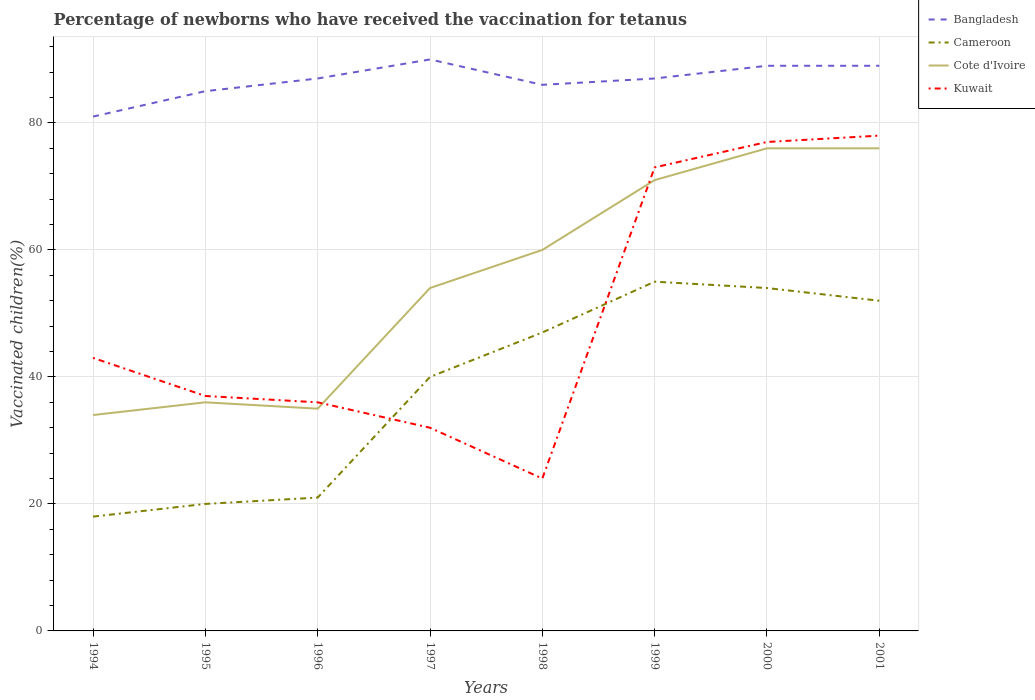How many different coloured lines are there?
Your answer should be compact. 4. Is the number of lines equal to the number of legend labels?
Give a very brief answer. Yes. Across all years, what is the maximum percentage of vaccinated children in Cameroon?
Offer a terse response. 18. In which year was the percentage of vaccinated children in Cote d'Ivoire maximum?
Make the answer very short. 1994. What is the difference between the highest and the second highest percentage of vaccinated children in Bangladesh?
Make the answer very short. 9. How many lines are there?
Make the answer very short. 4. What is the difference between two consecutive major ticks on the Y-axis?
Your answer should be compact. 20. Are the values on the major ticks of Y-axis written in scientific E-notation?
Ensure brevity in your answer.  No. Does the graph contain grids?
Offer a very short reply. Yes. How many legend labels are there?
Your response must be concise. 4. How are the legend labels stacked?
Your answer should be compact. Vertical. What is the title of the graph?
Your answer should be compact. Percentage of newborns who have received the vaccination for tetanus. What is the label or title of the X-axis?
Keep it short and to the point. Years. What is the label or title of the Y-axis?
Give a very brief answer. Vaccinated children(%). What is the Vaccinated children(%) of Cote d'Ivoire in 1994?
Provide a short and direct response. 34. What is the Vaccinated children(%) in Cameroon in 1995?
Give a very brief answer. 20. What is the Vaccinated children(%) in Cote d'Ivoire in 1995?
Keep it short and to the point. 36. What is the Vaccinated children(%) of Kuwait in 1995?
Your response must be concise. 37. What is the Vaccinated children(%) of Bangladesh in 1996?
Offer a terse response. 87. What is the Vaccinated children(%) of Kuwait in 1996?
Give a very brief answer. 36. What is the Vaccinated children(%) in Bangladesh in 1997?
Ensure brevity in your answer.  90. What is the Vaccinated children(%) of Cote d'Ivoire in 1997?
Your answer should be compact. 54. What is the Vaccinated children(%) in Kuwait in 1997?
Ensure brevity in your answer.  32. What is the Vaccinated children(%) of Cameroon in 1998?
Make the answer very short. 47. What is the Vaccinated children(%) in Cote d'Ivoire in 1998?
Your answer should be compact. 60. What is the Vaccinated children(%) of Kuwait in 1998?
Offer a very short reply. 24. What is the Vaccinated children(%) of Bangladesh in 1999?
Offer a very short reply. 87. What is the Vaccinated children(%) in Cameroon in 1999?
Provide a succinct answer. 55. What is the Vaccinated children(%) of Cote d'Ivoire in 1999?
Ensure brevity in your answer.  71. What is the Vaccinated children(%) in Bangladesh in 2000?
Provide a succinct answer. 89. What is the Vaccinated children(%) in Kuwait in 2000?
Keep it short and to the point. 77. What is the Vaccinated children(%) in Bangladesh in 2001?
Offer a terse response. 89. Across all years, what is the maximum Vaccinated children(%) in Bangladesh?
Your answer should be compact. 90. Across all years, what is the maximum Vaccinated children(%) of Cameroon?
Offer a terse response. 55. Across all years, what is the maximum Vaccinated children(%) in Cote d'Ivoire?
Your answer should be compact. 76. Across all years, what is the minimum Vaccinated children(%) in Bangladesh?
Your answer should be very brief. 81. Across all years, what is the minimum Vaccinated children(%) of Cameroon?
Keep it short and to the point. 18. Across all years, what is the minimum Vaccinated children(%) in Cote d'Ivoire?
Provide a succinct answer. 34. What is the total Vaccinated children(%) of Bangladesh in the graph?
Your response must be concise. 694. What is the total Vaccinated children(%) in Cameroon in the graph?
Keep it short and to the point. 307. What is the total Vaccinated children(%) in Cote d'Ivoire in the graph?
Provide a short and direct response. 442. What is the difference between the Vaccinated children(%) of Cote d'Ivoire in 1994 and that in 1995?
Your answer should be very brief. -2. What is the difference between the Vaccinated children(%) in Kuwait in 1994 and that in 1995?
Your response must be concise. 6. What is the difference between the Vaccinated children(%) in Cameroon in 1994 and that in 1996?
Keep it short and to the point. -3. What is the difference between the Vaccinated children(%) in Cameroon in 1994 and that in 1997?
Give a very brief answer. -22. What is the difference between the Vaccinated children(%) in Bangladesh in 1994 and that in 1998?
Offer a terse response. -5. What is the difference between the Vaccinated children(%) in Cameroon in 1994 and that in 1998?
Offer a very short reply. -29. What is the difference between the Vaccinated children(%) in Cote d'Ivoire in 1994 and that in 1998?
Your answer should be very brief. -26. What is the difference between the Vaccinated children(%) of Cameroon in 1994 and that in 1999?
Provide a succinct answer. -37. What is the difference between the Vaccinated children(%) in Cote d'Ivoire in 1994 and that in 1999?
Your answer should be compact. -37. What is the difference between the Vaccinated children(%) of Bangladesh in 1994 and that in 2000?
Keep it short and to the point. -8. What is the difference between the Vaccinated children(%) of Cameroon in 1994 and that in 2000?
Offer a very short reply. -36. What is the difference between the Vaccinated children(%) in Cote d'Ivoire in 1994 and that in 2000?
Your response must be concise. -42. What is the difference between the Vaccinated children(%) in Kuwait in 1994 and that in 2000?
Provide a succinct answer. -34. What is the difference between the Vaccinated children(%) in Bangladesh in 1994 and that in 2001?
Your answer should be compact. -8. What is the difference between the Vaccinated children(%) in Cameroon in 1994 and that in 2001?
Keep it short and to the point. -34. What is the difference between the Vaccinated children(%) of Cote d'Ivoire in 1994 and that in 2001?
Ensure brevity in your answer.  -42. What is the difference between the Vaccinated children(%) of Kuwait in 1994 and that in 2001?
Provide a succinct answer. -35. What is the difference between the Vaccinated children(%) of Kuwait in 1995 and that in 1997?
Your answer should be compact. 5. What is the difference between the Vaccinated children(%) of Cameroon in 1995 and that in 1998?
Offer a very short reply. -27. What is the difference between the Vaccinated children(%) in Cameroon in 1995 and that in 1999?
Give a very brief answer. -35. What is the difference between the Vaccinated children(%) of Cote d'Ivoire in 1995 and that in 1999?
Your response must be concise. -35. What is the difference between the Vaccinated children(%) in Kuwait in 1995 and that in 1999?
Give a very brief answer. -36. What is the difference between the Vaccinated children(%) in Cameroon in 1995 and that in 2000?
Keep it short and to the point. -34. What is the difference between the Vaccinated children(%) of Cote d'Ivoire in 1995 and that in 2000?
Ensure brevity in your answer.  -40. What is the difference between the Vaccinated children(%) of Kuwait in 1995 and that in 2000?
Provide a succinct answer. -40. What is the difference between the Vaccinated children(%) in Bangladesh in 1995 and that in 2001?
Your answer should be compact. -4. What is the difference between the Vaccinated children(%) of Cameroon in 1995 and that in 2001?
Provide a succinct answer. -32. What is the difference between the Vaccinated children(%) of Cote d'Ivoire in 1995 and that in 2001?
Your response must be concise. -40. What is the difference between the Vaccinated children(%) of Kuwait in 1995 and that in 2001?
Ensure brevity in your answer.  -41. What is the difference between the Vaccinated children(%) in Bangladesh in 1996 and that in 1997?
Your answer should be compact. -3. What is the difference between the Vaccinated children(%) of Cameroon in 1996 and that in 1997?
Ensure brevity in your answer.  -19. What is the difference between the Vaccinated children(%) in Kuwait in 1996 and that in 1997?
Provide a succinct answer. 4. What is the difference between the Vaccinated children(%) in Bangladesh in 1996 and that in 1998?
Offer a very short reply. 1. What is the difference between the Vaccinated children(%) of Cote d'Ivoire in 1996 and that in 1998?
Your response must be concise. -25. What is the difference between the Vaccinated children(%) of Bangladesh in 1996 and that in 1999?
Keep it short and to the point. 0. What is the difference between the Vaccinated children(%) of Cameroon in 1996 and that in 1999?
Make the answer very short. -34. What is the difference between the Vaccinated children(%) of Cote d'Ivoire in 1996 and that in 1999?
Make the answer very short. -36. What is the difference between the Vaccinated children(%) of Kuwait in 1996 and that in 1999?
Provide a succinct answer. -37. What is the difference between the Vaccinated children(%) in Bangladesh in 1996 and that in 2000?
Make the answer very short. -2. What is the difference between the Vaccinated children(%) of Cameroon in 1996 and that in 2000?
Offer a terse response. -33. What is the difference between the Vaccinated children(%) in Cote d'Ivoire in 1996 and that in 2000?
Provide a short and direct response. -41. What is the difference between the Vaccinated children(%) in Kuwait in 1996 and that in 2000?
Your response must be concise. -41. What is the difference between the Vaccinated children(%) of Cameroon in 1996 and that in 2001?
Ensure brevity in your answer.  -31. What is the difference between the Vaccinated children(%) in Cote d'Ivoire in 1996 and that in 2001?
Provide a short and direct response. -41. What is the difference between the Vaccinated children(%) of Kuwait in 1996 and that in 2001?
Your response must be concise. -42. What is the difference between the Vaccinated children(%) in Bangladesh in 1997 and that in 1998?
Provide a short and direct response. 4. What is the difference between the Vaccinated children(%) of Cote d'Ivoire in 1997 and that in 1998?
Give a very brief answer. -6. What is the difference between the Vaccinated children(%) of Kuwait in 1997 and that in 1998?
Give a very brief answer. 8. What is the difference between the Vaccinated children(%) in Bangladesh in 1997 and that in 1999?
Your answer should be very brief. 3. What is the difference between the Vaccinated children(%) in Cameroon in 1997 and that in 1999?
Ensure brevity in your answer.  -15. What is the difference between the Vaccinated children(%) of Kuwait in 1997 and that in 1999?
Your answer should be compact. -41. What is the difference between the Vaccinated children(%) of Kuwait in 1997 and that in 2000?
Make the answer very short. -45. What is the difference between the Vaccinated children(%) of Bangladesh in 1997 and that in 2001?
Ensure brevity in your answer.  1. What is the difference between the Vaccinated children(%) of Cameroon in 1997 and that in 2001?
Make the answer very short. -12. What is the difference between the Vaccinated children(%) in Kuwait in 1997 and that in 2001?
Your response must be concise. -46. What is the difference between the Vaccinated children(%) in Cameroon in 1998 and that in 1999?
Your response must be concise. -8. What is the difference between the Vaccinated children(%) in Cote d'Ivoire in 1998 and that in 1999?
Offer a very short reply. -11. What is the difference between the Vaccinated children(%) in Kuwait in 1998 and that in 1999?
Provide a succinct answer. -49. What is the difference between the Vaccinated children(%) of Bangladesh in 1998 and that in 2000?
Your answer should be compact. -3. What is the difference between the Vaccinated children(%) of Cameroon in 1998 and that in 2000?
Give a very brief answer. -7. What is the difference between the Vaccinated children(%) of Kuwait in 1998 and that in 2000?
Make the answer very short. -53. What is the difference between the Vaccinated children(%) in Bangladesh in 1998 and that in 2001?
Keep it short and to the point. -3. What is the difference between the Vaccinated children(%) in Cameroon in 1998 and that in 2001?
Provide a succinct answer. -5. What is the difference between the Vaccinated children(%) of Cote d'Ivoire in 1998 and that in 2001?
Provide a succinct answer. -16. What is the difference between the Vaccinated children(%) in Kuwait in 1998 and that in 2001?
Make the answer very short. -54. What is the difference between the Vaccinated children(%) of Cote d'Ivoire in 1999 and that in 2000?
Keep it short and to the point. -5. What is the difference between the Vaccinated children(%) of Kuwait in 1999 and that in 2000?
Your response must be concise. -4. What is the difference between the Vaccinated children(%) in Cameroon in 1999 and that in 2001?
Provide a succinct answer. 3. What is the difference between the Vaccinated children(%) of Cote d'Ivoire in 1999 and that in 2001?
Provide a succinct answer. -5. What is the difference between the Vaccinated children(%) in Kuwait in 1999 and that in 2001?
Offer a very short reply. -5. What is the difference between the Vaccinated children(%) of Cameroon in 2000 and that in 2001?
Offer a very short reply. 2. What is the difference between the Vaccinated children(%) in Kuwait in 2000 and that in 2001?
Provide a succinct answer. -1. What is the difference between the Vaccinated children(%) in Bangladesh in 1994 and the Vaccinated children(%) in Cameroon in 1995?
Provide a succinct answer. 61. What is the difference between the Vaccinated children(%) of Cote d'Ivoire in 1994 and the Vaccinated children(%) of Kuwait in 1995?
Your answer should be very brief. -3. What is the difference between the Vaccinated children(%) in Bangladesh in 1994 and the Vaccinated children(%) in Cote d'Ivoire in 1996?
Provide a short and direct response. 46. What is the difference between the Vaccinated children(%) of Bangladesh in 1994 and the Vaccinated children(%) of Kuwait in 1996?
Your response must be concise. 45. What is the difference between the Vaccinated children(%) of Cameroon in 1994 and the Vaccinated children(%) of Cote d'Ivoire in 1996?
Give a very brief answer. -17. What is the difference between the Vaccinated children(%) of Bangladesh in 1994 and the Vaccinated children(%) of Cameroon in 1997?
Give a very brief answer. 41. What is the difference between the Vaccinated children(%) in Bangladesh in 1994 and the Vaccinated children(%) in Cote d'Ivoire in 1997?
Offer a very short reply. 27. What is the difference between the Vaccinated children(%) of Cameroon in 1994 and the Vaccinated children(%) of Cote d'Ivoire in 1997?
Give a very brief answer. -36. What is the difference between the Vaccinated children(%) in Cameroon in 1994 and the Vaccinated children(%) in Kuwait in 1997?
Your response must be concise. -14. What is the difference between the Vaccinated children(%) of Cote d'Ivoire in 1994 and the Vaccinated children(%) of Kuwait in 1997?
Ensure brevity in your answer.  2. What is the difference between the Vaccinated children(%) of Bangladesh in 1994 and the Vaccinated children(%) of Kuwait in 1998?
Provide a short and direct response. 57. What is the difference between the Vaccinated children(%) of Cameroon in 1994 and the Vaccinated children(%) of Cote d'Ivoire in 1998?
Ensure brevity in your answer.  -42. What is the difference between the Vaccinated children(%) in Cameroon in 1994 and the Vaccinated children(%) in Kuwait in 1998?
Ensure brevity in your answer.  -6. What is the difference between the Vaccinated children(%) of Bangladesh in 1994 and the Vaccinated children(%) of Cameroon in 1999?
Offer a very short reply. 26. What is the difference between the Vaccinated children(%) of Bangladesh in 1994 and the Vaccinated children(%) of Cote d'Ivoire in 1999?
Provide a short and direct response. 10. What is the difference between the Vaccinated children(%) of Cameroon in 1994 and the Vaccinated children(%) of Cote d'Ivoire in 1999?
Your answer should be very brief. -53. What is the difference between the Vaccinated children(%) in Cameroon in 1994 and the Vaccinated children(%) in Kuwait in 1999?
Your answer should be very brief. -55. What is the difference between the Vaccinated children(%) in Cote d'Ivoire in 1994 and the Vaccinated children(%) in Kuwait in 1999?
Make the answer very short. -39. What is the difference between the Vaccinated children(%) of Bangladesh in 1994 and the Vaccinated children(%) of Cameroon in 2000?
Your answer should be compact. 27. What is the difference between the Vaccinated children(%) in Bangladesh in 1994 and the Vaccinated children(%) in Cote d'Ivoire in 2000?
Provide a succinct answer. 5. What is the difference between the Vaccinated children(%) of Bangladesh in 1994 and the Vaccinated children(%) of Kuwait in 2000?
Your answer should be very brief. 4. What is the difference between the Vaccinated children(%) of Cameroon in 1994 and the Vaccinated children(%) of Cote d'Ivoire in 2000?
Keep it short and to the point. -58. What is the difference between the Vaccinated children(%) of Cameroon in 1994 and the Vaccinated children(%) of Kuwait in 2000?
Your answer should be compact. -59. What is the difference between the Vaccinated children(%) in Cote d'Ivoire in 1994 and the Vaccinated children(%) in Kuwait in 2000?
Your answer should be compact. -43. What is the difference between the Vaccinated children(%) of Cameroon in 1994 and the Vaccinated children(%) of Cote d'Ivoire in 2001?
Ensure brevity in your answer.  -58. What is the difference between the Vaccinated children(%) of Cameroon in 1994 and the Vaccinated children(%) of Kuwait in 2001?
Your answer should be compact. -60. What is the difference between the Vaccinated children(%) in Cote d'Ivoire in 1994 and the Vaccinated children(%) in Kuwait in 2001?
Your response must be concise. -44. What is the difference between the Vaccinated children(%) of Bangladesh in 1995 and the Vaccinated children(%) of Cote d'Ivoire in 1996?
Your answer should be very brief. 50. What is the difference between the Vaccinated children(%) in Cameroon in 1995 and the Vaccinated children(%) in Cote d'Ivoire in 1996?
Give a very brief answer. -15. What is the difference between the Vaccinated children(%) in Bangladesh in 1995 and the Vaccinated children(%) in Cote d'Ivoire in 1997?
Provide a succinct answer. 31. What is the difference between the Vaccinated children(%) of Cameroon in 1995 and the Vaccinated children(%) of Cote d'Ivoire in 1997?
Your answer should be compact. -34. What is the difference between the Vaccinated children(%) in Cote d'Ivoire in 1995 and the Vaccinated children(%) in Kuwait in 1997?
Offer a terse response. 4. What is the difference between the Vaccinated children(%) in Cameroon in 1995 and the Vaccinated children(%) in Cote d'Ivoire in 1998?
Ensure brevity in your answer.  -40. What is the difference between the Vaccinated children(%) of Bangladesh in 1995 and the Vaccinated children(%) of Cote d'Ivoire in 1999?
Your answer should be very brief. 14. What is the difference between the Vaccinated children(%) in Bangladesh in 1995 and the Vaccinated children(%) in Kuwait in 1999?
Your answer should be very brief. 12. What is the difference between the Vaccinated children(%) in Cameroon in 1995 and the Vaccinated children(%) in Cote d'Ivoire in 1999?
Your response must be concise. -51. What is the difference between the Vaccinated children(%) in Cameroon in 1995 and the Vaccinated children(%) in Kuwait in 1999?
Offer a terse response. -53. What is the difference between the Vaccinated children(%) in Cote d'Ivoire in 1995 and the Vaccinated children(%) in Kuwait in 1999?
Keep it short and to the point. -37. What is the difference between the Vaccinated children(%) of Bangladesh in 1995 and the Vaccinated children(%) of Kuwait in 2000?
Provide a short and direct response. 8. What is the difference between the Vaccinated children(%) in Cameroon in 1995 and the Vaccinated children(%) in Cote d'Ivoire in 2000?
Offer a very short reply. -56. What is the difference between the Vaccinated children(%) in Cameroon in 1995 and the Vaccinated children(%) in Kuwait in 2000?
Provide a succinct answer. -57. What is the difference between the Vaccinated children(%) in Cote d'Ivoire in 1995 and the Vaccinated children(%) in Kuwait in 2000?
Offer a very short reply. -41. What is the difference between the Vaccinated children(%) in Bangladesh in 1995 and the Vaccinated children(%) in Cote d'Ivoire in 2001?
Offer a very short reply. 9. What is the difference between the Vaccinated children(%) of Bangladesh in 1995 and the Vaccinated children(%) of Kuwait in 2001?
Your answer should be compact. 7. What is the difference between the Vaccinated children(%) in Cameroon in 1995 and the Vaccinated children(%) in Cote d'Ivoire in 2001?
Provide a short and direct response. -56. What is the difference between the Vaccinated children(%) in Cameroon in 1995 and the Vaccinated children(%) in Kuwait in 2001?
Give a very brief answer. -58. What is the difference between the Vaccinated children(%) of Cote d'Ivoire in 1995 and the Vaccinated children(%) of Kuwait in 2001?
Ensure brevity in your answer.  -42. What is the difference between the Vaccinated children(%) in Bangladesh in 1996 and the Vaccinated children(%) in Cote d'Ivoire in 1997?
Ensure brevity in your answer.  33. What is the difference between the Vaccinated children(%) of Cameroon in 1996 and the Vaccinated children(%) of Cote d'Ivoire in 1997?
Your answer should be very brief. -33. What is the difference between the Vaccinated children(%) of Cameroon in 1996 and the Vaccinated children(%) of Kuwait in 1997?
Your response must be concise. -11. What is the difference between the Vaccinated children(%) of Bangladesh in 1996 and the Vaccinated children(%) of Cameroon in 1998?
Your answer should be very brief. 40. What is the difference between the Vaccinated children(%) in Bangladesh in 1996 and the Vaccinated children(%) in Cote d'Ivoire in 1998?
Keep it short and to the point. 27. What is the difference between the Vaccinated children(%) in Cameroon in 1996 and the Vaccinated children(%) in Cote d'Ivoire in 1998?
Give a very brief answer. -39. What is the difference between the Vaccinated children(%) in Cameroon in 1996 and the Vaccinated children(%) in Kuwait in 1998?
Your response must be concise. -3. What is the difference between the Vaccinated children(%) of Cote d'Ivoire in 1996 and the Vaccinated children(%) of Kuwait in 1998?
Offer a very short reply. 11. What is the difference between the Vaccinated children(%) of Bangladesh in 1996 and the Vaccinated children(%) of Cameroon in 1999?
Provide a succinct answer. 32. What is the difference between the Vaccinated children(%) in Bangladesh in 1996 and the Vaccinated children(%) in Kuwait in 1999?
Your response must be concise. 14. What is the difference between the Vaccinated children(%) in Cameroon in 1996 and the Vaccinated children(%) in Kuwait in 1999?
Offer a very short reply. -52. What is the difference between the Vaccinated children(%) in Cote d'Ivoire in 1996 and the Vaccinated children(%) in Kuwait in 1999?
Offer a terse response. -38. What is the difference between the Vaccinated children(%) of Bangladesh in 1996 and the Vaccinated children(%) of Cote d'Ivoire in 2000?
Provide a succinct answer. 11. What is the difference between the Vaccinated children(%) in Bangladesh in 1996 and the Vaccinated children(%) in Kuwait in 2000?
Your answer should be compact. 10. What is the difference between the Vaccinated children(%) of Cameroon in 1996 and the Vaccinated children(%) of Cote d'Ivoire in 2000?
Keep it short and to the point. -55. What is the difference between the Vaccinated children(%) in Cameroon in 1996 and the Vaccinated children(%) in Kuwait in 2000?
Keep it short and to the point. -56. What is the difference between the Vaccinated children(%) in Cote d'Ivoire in 1996 and the Vaccinated children(%) in Kuwait in 2000?
Offer a terse response. -42. What is the difference between the Vaccinated children(%) in Bangladesh in 1996 and the Vaccinated children(%) in Cameroon in 2001?
Give a very brief answer. 35. What is the difference between the Vaccinated children(%) in Bangladesh in 1996 and the Vaccinated children(%) in Kuwait in 2001?
Offer a very short reply. 9. What is the difference between the Vaccinated children(%) of Cameroon in 1996 and the Vaccinated children(%) of Cote d'Ivoire in 2001?
Ensure brevity in your answer.  -55. What is the difference between the Vaccinated children(%) in Cameroon in 1996 and the Vaccinated children(%) in Kuwait in 2001?
Provide a short and direct response. -57. What is the difference between the Vaccinated children(%) of Cote d'Ivoire in 1996 and the Vaccinated children(%) of Kuwait in 2001?
Provide a short and direct response. -43. What is the difference between the Vaccinated children(%) of Bangladesh in 1997 and the Vaccinated children(%) of Kuwait in 1998?
Give a very brief answer. 66. What is the difference between the Vaccinated children(%) of Cameroon in 1997 and the Vaccinated children(%) of Cote d'Ivoire in 1998?
Keep it short and to the point. -20. What is the difference between the Vaccinated children(%) in Cameroon in 1997 and the Vaccinated children(%) in Kuwait in 1998?
Provide a short and direct response. 16. What is the difference between the Vaccinated children(%) of Cote d'Ivoire in 1997 and the Vaccinated children(%) of Kuwait in 1998?
Offer a very short reply. 30. What is the difference between the Vaccinated children(%) in Bangladesh in 1997 and the Vaccinated children(%) in Cote d'Ivoire in 1999?
Your response must be concise. 19. What is the difference between the Vaccinated children(%) in Cameroon in 1997 and the Vaccinated children(%) in Cote d'Ivoire in 1999?
Your response must be concise. -31. What is the difference between the Vaccinated children(%) in Cameroon in 1997 and the Vaccinated children(%) in Kuwait in 1999?
Make the answer very short. -33. What is the difference between the Vaccinated children(%) of Cote d'Ivoire in 1997 and the Vaccinated children(%) of Kuwait in 1999?
Make the answer very short. -19. What is the difference between the Vaccinated children(%) of Cameroon in 1997 and the Vaccinated children(%) of Cote d'Ivoire in 2000?
Provide a short and direct response. -36. What is the difference between the Vaccinated children(%) of Cameroon in 1997 and the Vaccinated children(%) of Kuwait in 2000?
Your response must be concise. -37. What is the difference between the Vaccinated children(%) in Bangladesh in 1997 and the Vaccinated children(%) in Cote d'Ivoire in 2001?
Provide a short and direct response. 14. What is the difference between the Vaccinated children(%) of Cameroon in 1997 and the Vaccinated children(%) of Cote d'Ivoire in 2001?
Make the answer very short. -36. What is the difference between the Vaccinated children(%) in Cameroon in 1997 and the Vaccinated children(%) in Kuwait in 2001?
Offer a very short reply. -38. What is the difference between the Vaccinated children(%) of Bangladesh in 1998 and the Vaccinated children(%) of Kuwait in 1999?
Ensure brevity in your answer.  13. What is the difference between the Vaccinated children(%) in Cameroon in 1998 and the Vaccinated children(%) in Cote d'Ivoire in 1999?
Ensure brevity in your answer.  -24. What is the difference between the Vaccinated children(%) of Cameroon in 1998 and the Vaccinated children(%) of Kuwait in 1999?
Provide a short and direct response. -26. What is the difference between the Vaccinated children(%) of Cote d'Ivoire in 1998 and the Vaccinated children(%) of Kuwait in 1999?
Provide a short and direct response. -13. What is the difference between the Vaccinated children(%) of Bangladesh in 1998 and the Vaccinated children(%) of Cameroon in 2000?
Your answer should be very brief. 32. What is the difference between the Vaccinated children(%) in Bangladesh in 1998 and the Vaccinated children(%) in Cote d'Ivoire in 2000?
Provide a short and direct response. 10. What is the difference between the Vaccinated children(%) in Cameroon in 1998 and the Vaccinated children(%) in Cote d'Ivoire in 2000?
Your response must be concise. -29. What is the difference between the Vaccinated children(%) in Cote d'Ivoire in 1998 and the Vaccinated children(%) in Kuwait in 2000?
Ensure brevity in your answer.  -17. What is the difference between the Vaccinated children(%) of Bangladesh in 1998 and the Vaccinated children(%) of Cote d'Ivoire in 2001?
Your answer should be very brief. 10. What is the difference between the Vaccinated children(%) of Cameroon in 1998 and the Vaccinated children(%) of Kuwait in 2001?
Keep it short and to the point. -31. What is the difference between the Vaccinated children(%) of Bangladesh in 1999 and the Vaccinated children(%) of Cameroon in 2000?
Make the answer very short. 33. What is the difference between the Vaccinated children(%) in Bangladesh in 1999 and the Vaccinated children(%) in Cote d'Ivoire in 2000?
Ensure brevity in your answer.  11. What is the difference between the Vaccinated children(%) of Cameroon in 1999 and the Vaccinated children(%) of Cote d'Ivoire in 2000?
Your answer should be very brief. -21. What is the difference between the Vaccinated children(%) in Cameroon in 1999 and the Vaccinated children(%) in Kuwait in 2000?
Provide a short and direct response. -22. What is the difference between the Vaccinated children(%) of Bangladesh in 1999 and the Vaccinated children(%) of Cameroon in 2001?
Your answer should be very brief. 35. What is the difference between the Vaccinated children(%) in Bangladesh in 1999 and the Vaccinated children(%) in Cote d'Ivoire in 2001?
Your answer should be compact. 11. What is the difference between the Vaccinated children(%) of Cameroon in 1999 and the Vaccinated children(%) of Kuwait in 2001?
Give a very brief answer. -23. What is the difference between the Vaccinated children(%) in Cote d'Ivoire in 1999 and the Vaccinated children(%) in Kuwait in 2001?
Give a very brief answer. -7. What is the difference between the Vaccinated children(%) in Bangladesh in 2000 and the Vaccinated children(%) in Cameroon in 2001?
Ensure brevity in your answer.  37. What is the difference between the Vaccinated children(%) in Bangladesh in 2000 and the Vaccinated children(%) in Cote d'Ivoire in 2001?
Keep it short and to the point. 13. What is the difference between the Vaccinated children(%) in Bangladesh in 2000 and the Vaccinated children(%) in Kuwait in 2001?
Your answer should be compact. 11. What is the difference between the Vaccinated children(%) of Cameroon in 2000 and the Vaccinated children(%) of Kuwait in 2001?
Keep it short and to the point. -24. What is the average Vaccinated children(%) of Bangladesh per year?
Your response must be concise. 86.75. What is the average Vaccinated children(%) of Cameroon per year?
Offer a very short reply. 38.38. What is the average Vaccinated children(%) of Cote d'Ivoire per year?
Ensure brevity in your answer.  55.25. In the year 1994, what is the difference between the Vaccinated children(%) in Cameroon and Vaccinated children(%) in Kuwait?
Offer a terse response. -25. In the year 1995, what is the difference between the Vaccinated children(%) of Bangladesh and Vaccinated children(%) of Cameroon?
Your answer should be very brief. 65. In the year 1995, what is the difference between the Vaccinated children(%) of Cameroon and Vaccinated children(%) of Kuwait?
Make the answer very short. -17. In the year 1995, what is the difference between the Vaccinated children(%) of Cote d'Ivoire and Vaccinated children(%) of Kuwait?
Keep it short and to the point. -1. In the year 1996, what is the difference between the Vaccinated children(%) of Bangladesh and Vaccinated children(%) of Kuwait?
Make the answer very short. 51. In the year 1996, what is the difference between the Vaccinated children(%) in Cote d'Ivoire and Vaccinated children(%) in Kuwait?
Ensure brevity in your answer.  -1. In the year 1997, what is the difference between the Vaccinated children(%) in Bangladesh and Vaccinated children(%) in Cote d'Ivoire?
Offer a terse response. 36. In the year 1997, what is the difference between the Vaccinated children(%) of Cameroon and Vaccinated children(%) of Cote d'Ivoire?
Your answer should be compact. -14. In the year 1997, what is the difference between the Vaccinated children(%) of Cameroon and Vaccinated children(%) of Kuwait?
Keep it short and to the point. 8. In the year 1998, what is the difference between the Vaccinated children(%) of Cameroon and Vaccinated children(%) of Cote d'Ivoire?
Make the answer very short. -13. In the year 1999, what is the difference between the Vaccinated children(%) in Bangladesh and Vaccinated children(%) in Cote d'Ivoire?
Offer a terse response. 16. In the year 1999, what is the difference between the Vaccinated children(%) of Bangladesh and Vaccinated children(%) of Kuwait?
Make the answer very short. 14. In the year 2000, what is the difference between the Vaccinated children(%) of Bangladesh and Vaccinated children(%) of Cote d'Ivoire?
Ensure brevity in your answer.  13. In the year 2000, what is the difference between the Vaccinated children(%) in Cameroon and Vaccinated children(%) in Kuwait?
Keep it short and to the point. -23. In the year 2000, what is the difference between the Vaccinated children(%) in Cote d'Ivoire and Vaccinated children(%) in Kuwait?
Provide a short and direct response. -1. In the year 2001, what is the difference between the Vaccinated children(%) in Cameroon and Vaccinated children(%) in Kuwait?
Your response must be concise. -26. What is the ratio of the Vaccinated children(%) of Bangladesh in 1994 to that in 1995?
Provide a short and direct response. 0.95. What is the ratio of the Vaccinated children(%) of Kuwait in 1994 to that in 1995?
Provide a succinct answer. 1.16. What is the ratio of the Vaccinated children(%) in Bangladesh in 1994 to that in 1996?
Keep it short and to the point. 0.93. What is the ratio of the Vaccinated children(%) of Cameroon in 1994 to that in 1996?
Ensure brevity in your answer.  0.86. What is the ratio of the Vaccinated children(%) of Cote d'Ivoire in 1994 to that in 1996?
Provide a succinct answer. 0.97. What is the ratio of the Vaccinated children(%) in Kuwait in 1994 to that in 1996?
Provide a short and direct response. 1.19. What is the ratio of the Vaccinated children(%) of Cameroon in 1994 to that in 1997?
Your answer should be compact. 0.45. What is the ratio of the Vaccinated children(%) of Cote d'Ivoire in 1994 to that in 1997?
Your answer should be very brief. 0.63. What is the ratio of the Vaccinated children(%) of Kuwait in 1994 to that in 1997?
Ensure brevity in your answer.  1.34. What is the ratio of the Vaccinated children(%) in Bangladesh in 1994 to that in 1998?
Make the answer very short. 0.94. What is the ratio of the Vaccinated children(%) of Cameroon in 1994 to that in 1998?
Your answer should be compact. 0.38. What is the ratio of the Vaccinated children(%) of Cote d'Ivoire in 1994 to that in 1998?
Ensure brevity in your answer.  0.57. What is the ratio of the Vaccinated children(%) in Kuwait in 1994 to that in 1998?
Your answer should be very brief. 1.79. What is the ratio of the Vaccinated children(%) of Bangladesh in 1994 to that in 1999?
Give a very brief answer. 0.93. What is the ratio of the Vaccinated children(%) of Cameroon in 1994 to that in 1999?
Provide a short and direct response. 0.33. What is the ratio of the Vaccinated children(%) of Cote d'Ivoire in 1994 to that in 1999?
Your answer should be very brief. 0.48. What is the ratio of the Vaccinated children(%) in Kuwait in 1994 to that in 1999?
Provide a succinct answer. 0.59. What is the ratio of the Vaccinated children(%) in Bangladesh in 1994 to that in 2000?
Your answer should be very brief. 0.91. What is the ratio of the Vaccinated children(%) in Cameroon in 1994 to that in 2000?
Offer a terse response. 0.33. What is the ratio of the Vaccinated children(%) in Cote d'Ivoire in 1994 to that in 2000?
Offer a very short reply. 0.45. What is the ratio of the Vaccinated children(%) of Kuwait in 1994 to that in 2000?
Ensure brevity in your answer.  0.56. What is the ratio of the Vaccinated children(%) of Bangladesh in 1994 to that in 2001?
Keep it short and to the point. 0.91. What is the ratio of the Vaccinated children(%) of Cameroon in 1994 to that in 2001?
Keep it short and to the point. 0.35. What is the ratio of the Vaccinated children(%) in Cote d'Ivoire in 1994 to that in 2001?
Your answer should be compact. 0.45. What is the ratio of the Vaccinated children(%) of Kuwait in 1994 to that in 2001?
Provide a succinct answer. 0.55. What is the ratio of the Vaccinated children(%) of Cote d'Ivoire in 1995 to that in 1996?
Give a very brief answer. 1.03. What is the ratio of the Vaccinated children(%) of Kuwait in 1995 to that in 1996?
Provide a succinct answer. 1.03. What is the ratio of the Vaccinated children(%) in Bangladesh in 1995 to that in 1997?
Offer a terse response. 0.94. What is the ratio of the Vaccinated children(%) in Cameroon in 1995 to that in 1997?
Your response must be concise. 0.5. What is the ratio of the Vaccinated children(%) of Kuwait in 1995 to that in 1997?
Your response must be concise. 1.16. What is the ratio of the Vaccinated children(%) of Bangladesh in 1995 to that in 1998?
Offer a terse response. 0.99. What is the ratio of the Vaccinated children(%) of Cameroon in 1995 to that in 1998?
Provide a succinct answer. 0.43. What is the ratio of the Vaccinated children(%) in Kuwait in 1995 to that in 1998?
Offer a very short reply. 1.54. What is the ratio of the Vaccinated children(%) of Cameroon in 1995 to that in 1999?
Provide a succinct answer. 0.36. What is the ratio of the Vaccinated children(%) of Cote d'Ivoire in 1995 to that in 1999?
Offer a very short reply. 0.51. What is the ratio of the Vaccinated children(%) of Kuwait in 1995 to that in 1999?
Make the answer very short. 0.51. What is the ratio of the Vaccinated children(%) of Bangladesh in 1995 to that in 2000?
Your answer should be compact. 0.96. What is the ratio of the Vaccinated children(%) of Cameroon in 1995 to that in 2000?
Your response must be concise. 0.37. What is the ratio of the Vaccinated children(%) in Cote d'Ivoire in 1995 to that in 2000?
Give a very brief answer. 0.47. What is the ratio of the Vaccinated children(%) of Kuwait in 1995 to that in 2000?
Give a very brief answer. 0.48. What is the ratio of the Vaccinated children(%) of Bangladesh in 1995 to that in 2001?
Ensure brevity in your answer.  0.96. What is the ratio of the Vaccinated children(%) in Cameroon in 1995 to that in 2001?
Give a very brief answer. 0.38. What is the ratio of the Vaccinated children(%) of Cote d'Ivoire in 1995 to that in 2001?
Give a very brief answer. 0.47. What is the ratio of the Vaccinated children(%) of Kuwait in 1995 to that in 2001?
Give a very brief answer. 0.47. What is the ratio of the Vaccinated children(%) of Bangladesh in 1996 to that in 1997?
Provide a succinct answer. 0.97. What is the ratio of the Vaccinated children(%) of Cameroon in 1996 to that in 1997?
Offer a very short reply. 0.53. What is the ratio of the Vaccinated children(%) in Cote d'Ivoire in 1996 to that in 1997?
Provide a succinct answer. 0.65. What is the ratio of the Vaccinated children(%) in Bangladesh in 1996 to that in 1998?
Provide a short and direct response. 1.01. What is the ratio of the Vaccinated children(%) in Cameroon in 1996 to that in 1998?
Your answer should be compact. 0.45. What is the ratio of the Vaccinated children(%) in Cote d'Ivoire in 1996 to that in 1998?
Give a very brief answer. 0.58. What is the ratio of the Vaccinated children(%) of Bangladesh in 1996 to that in 1999?
Give a very brief answer. 1. What is the ratio of the Vaccinated children(%) in Cameroon in 1996 to that in 1999?
Make the answer very short. 0.38. What is the ratio of the Vaccinated children(%) in Cote d'Ivoire in 1996 to that in 1999?
Provide a short and direct response. 0.49. What is the ratio of the Vaccinated children(%) in Kuwait in 1996 to that in 1999?
Your response must be concise. 0.49. What is the ratio of the Vaccinated children(%) of Bangladesh in 1996 to that in 2000?
Your response must be concise. 0.98. What is the ratio of the Vaccinated children(%) of Cameroon in 1996 to that in 2000?
Ensure brevity in your answer.  0.39. What is the ratio of the Vaccinated children(%) of Cote d'Ivoire in 1996 to that in 2000?
Give a very brief answer. 0.46. What is the ratio of the Vaccinated children(%) in Kuwait in 1996 to that in 2000?
Give a very brief answer. 0.47. What is the ratio of the Vaccinated children(%) in Bangladesh in 1996 to that in 2001?
Offer a very short reply. 0.98. What is the ratio of the Vaccinated children(%) of Cameroon in 1996 to that in 2001?
Your answer should be very brief. 0.4. What is the ratio of the Vaccinated children(%) of Cote d'Ivoire in 1996 to that in 2001?
Give a very brief answer. 0.46. What is the ratio of the Vaccinated children(%) in Kuwait in 1996 to that in 2001?
Give a very brief answer. 0.46. What is the ratio of the Vaccinated children(%) in Bangladesh in 1997 to that in 1998?
Provide a succinct answer. 1.05. What is the ratio of the Vaccinated children(%) of Cameroon in 1997 to that in 1998?
Your response must be concise. 0.85. What is the ratio of the Vaccinated children(%) in Bangladesh in 1997 to that in 1999?
Your response must be concise. 1.03. What is the ratio of the Vaccinated children(%) of Cameroon in 1997 to that in 1999?
Your answer should be very brief. 0.73. What is the ratio of the Vaccinated children(%) of Cote d'Ivoire in 1997 to that in 1999?
Your answer should be compact. 0.76. What is the ratio of the Vaccinated children(%) in Kuwait in 1997 to that in 1999?
Your answer should be compact. 0.44. What is the ratio of the Vaccinated children(%) in Bangladesh in 1997 to that in 2000?
Your response must be concise. 1.01. What is the ratio of the Vaccinated children(%) of Cameroon in 1997 to that in 2000?
Make the answer very short. 0.74. What is the ratio of the Vaccinated children(%) of Cote d'Ivoire in 1997 to that in 2000?
Ensure brevity in your answer.  0.71. What is the ratio of the Vaccinated children(%) of Kuwait in 1997 to that in 2000?
Your response must be concise. 0.42. What is the ratio of the Vaccinated children(%) of Bangladesh in 1997 to that in 2001?
Your response must be concise. 1.01. What is the ratio of the Vaccinated children(%) in Cameroon in 1997 to that in 2001?
Ensure brevity in your answer.  0.77. What is the ratio of the Vaccinated children(%) of Cote d'Ivoire in 1997 to that in 2001?
Your answer should be very brief. 0.71. What is the ratio of the Vaccinated children(%) of Kuwait in 1997 to that in 2001?
Provide a succinct answer. 0.41. What is the ratio of the Vaccinated children(%) in Cameroon in 1998 to that in 1999?
Make the answer very short. 0.85. What is the ratio of the Vaccinated children(%) of Cote d'Ivoire in 1998 to that in 1999?
Your answer should be very brief. 0.85. What is the ratio of the Vaccinated children(%) in Kuwait in 1998 to that in 1999?
Keep it short and to the point. 0.33. What is the ratio of the Vaccinated children(%) of Bangladesh in 1998 to that in 2000?
Offer a terse response. 0.97. What is the ratio of the Vaccinated children(%) in Cameroon in 1998 to that in 2000?
Offer a very short reply. 0.87. What is the ratio of the Vaccinated children(%) of Cote d'Ivoire in 1998 to that in 2000?
Make the answer very short. 0.79. What is the ratio of the Vaccinated children(%) of Kuwait in 1998 to that in 2000?
Give a very brief answer. 0.31. What is the ratio of the Vaccinated children(%) of Bangladesh in 1998 to that in 2001?
Your answer should be very brief. 0.97. What is the ratio of the Vaccinated children(%) of Cameroon in 1998 to that in 2001?
Your answer should be very brief. 0.9. What is the ratio of the Vaccinated children(%) of Cote d'Ivoire in 1998 to that in 2001?
Give a very brief answer. 0.79. What is the ratio of the Vaccinated children(%) in Kuwait in 1998 to that in 2001?
Your answer should be compact. 0.31. What is the ratio of the Vaccinated children(%) in Bangladesh in 1999 to that in 2000?
Offer a very short reply. 0.98. What is the ratio of the Vaccinated children(%) of Cameroon in 1999 to that in 2000?
Your answer should be very brief. 1.02. What is the ratio of the Vaccinated children(%) in Cote d'Ivoire in 1999 to that in 2000?
Give a very brief answer. 0.93. What is the ratio of the Vaccinated children(%) of Kuwait in 1999 to that in 2000?
Your answer should be compact. 0.95. What is the ratio of the Vaccinated children(%) in Bangladesh in 1999 to that in 2001?
Provide a succinct answer. 0.98. What is the ratio of the Vaccinated children(%) in Cameroon in 1999 to that in 2001?
Your response must be concise. 1.06. What is the ratio of the Vaccinated children(%) in Cote d'Ivoire in 1999 to that in 2001?
Your answer should be compact. 0.93. What is the ratio of the Vaccinated children(%) in Kuwait in 1999 to that in 2001?
Keep it short and to the point. 0.94. What is the ratio of the Vaccinated children(%) of Cote d'Ivoire in 2000 to that in 2001?
Offer a terse response. 1. What is the ratio of the Vaccinated children(%) of Kuwait in 2000 to that in 2001?
Provide a short and direct response. 0.99. What is the difference between the highest and the second highest Vaccinated children(%) of Kuwait?
Offer a terse response. 1. What is the difference between the highest and the lowest Vaccinated children(%) in Bangladesh?
Ensure brevity in your answer.  9. What is the difference between the highest and the lowest Vaccinated children(%) in Cameroon?
Your answer should be very brief. 37. What is the difference between the highest and the lowest Vaccinated children(%) of Kuwait?
Offer a very short reply. 54. 